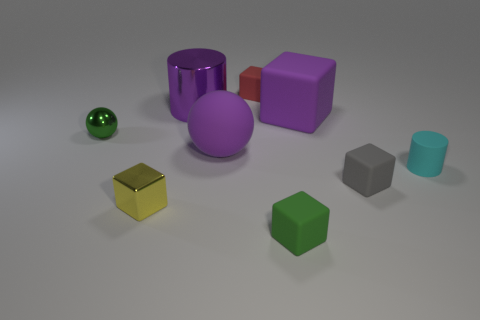What color is the rubber sphere that is the same size as the purple block?
Provide a short and direct response. Purple. The small object that is on the left side of the red block and to the right of the shiny sphere has what shape?
Your answer should be compact. Cube. There is a ball that is on the right side of the tiny cube to the left of the red matte block; how big is it?
Ensure brevity in your answer.  Large. What number of large rubber things are the same color as the rubber cylinder?
Your response must be concise. 0. What number of other things are there of the same size as the green matte block?
Keep it short and to the point. 5. There is a block that is in front of the big matte cube and behind the yellow cube; what size is it?
Provide a short and direct response. Small. How many tiny gray objects are the same shape as the red thing?
Make the answer very short. 1. What material is the purple sphere?
Your answer should be very brief. Rubber. Does the tiny green metallic thing have the same shape as the red thing?
Make the answer very short. No. Are there any small cubes that have the same material as the cyan object?
Provide a succinct answer. Yes. 